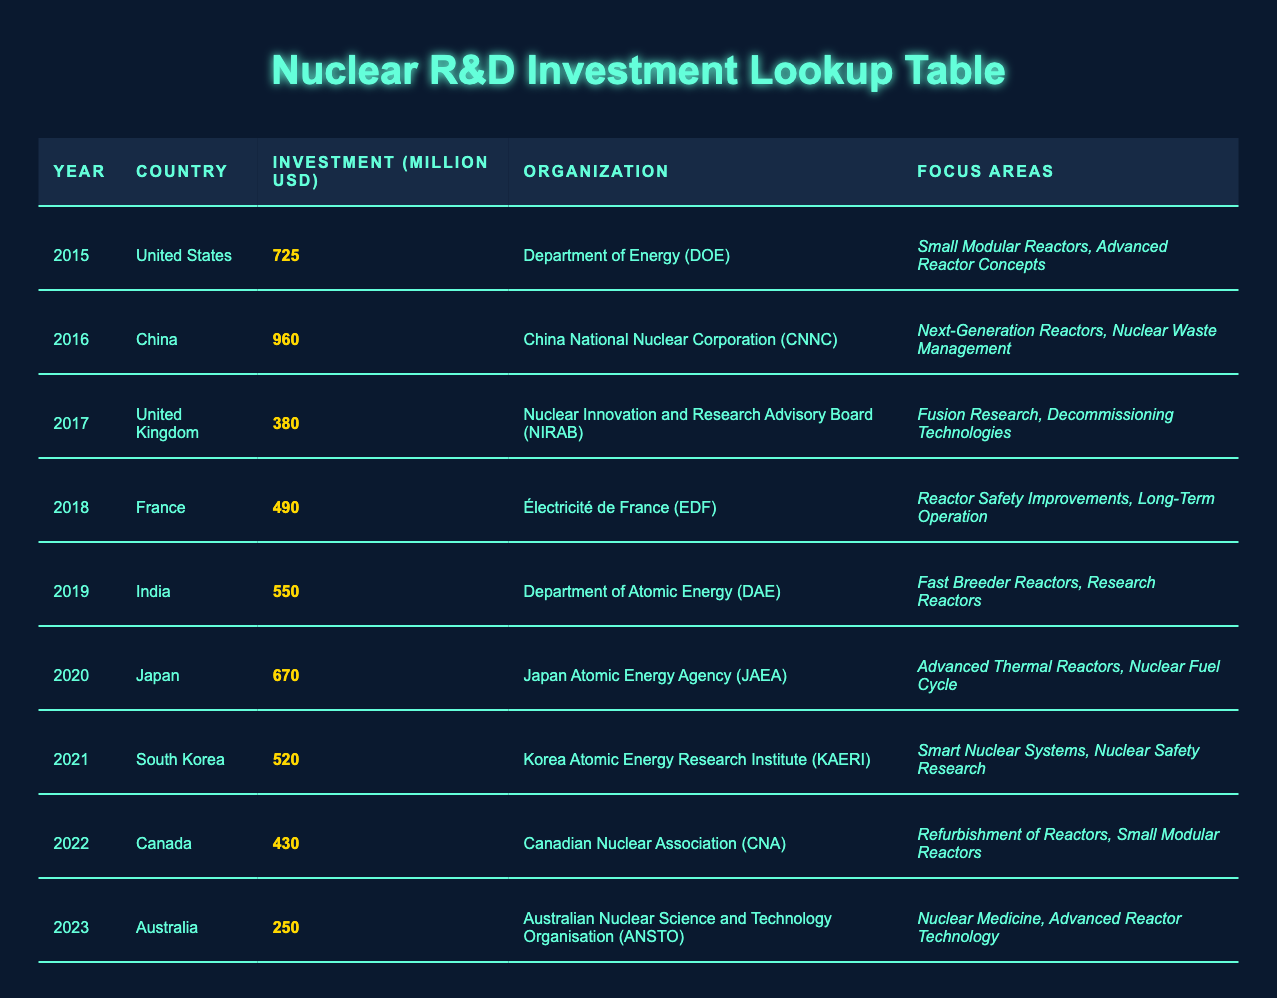What year had the highest investment in nuclear R&D? By reviewing the investment amounts listed for each year, we see that China in 2016 had an investment of 960 million USD, which is the highest amount compared to other years.
Answer: 2016 Which organization invested in nuclear R&D in Japan? The table specifies that the Japan Atomic Energy Agency (JAEA) was the organization responsible for nuclear R&D investment in Japan for the year 2020.
Answer: Japan Atomic Energy Agency (JAEA) How much did Canada invest in nuclear R&D in 2022? According to the table, Canada's investment in nuclear R&D in 2022 was 430 million USD, which is clearly stated in the respective row for that year.
Answer: 430 million USD What is the total investment in nuclear R&D from 2015 to 2020? To find the total investment from 2015 to 2020, we sum the investments for those years: 725 (2015) + 960 (2016) + 380 (2017) + 490 (2018) + 550 (2019) + 670 (2020) = 4075 million USD.
Answer: 4075 million USD Was any investment made in the field of Fusion Research? Yes, the table indicates that the United Kingdom, through the Nuclear Innovation and Research Advisory Board (NIRAB), invested in Fusion Research in 2017.
Answer: Yes Which country has the least investment in nuclear R&D, and what was the amount? By comparing all the investment amounts, we find that Australia had the lowest investment in 2023, with an amount of 250 million USD.
Answer: Australia, 250 million USD What was the average investment in nuclear R&D during the years listed in the table? Calculate the total investment from all the years (725 + 960 + 380 + 490 + 550 + 670 + 520 + 430 + 250) = 4575 million USD. There are 9 years, so the average is 4575 / 9 ≈ 508.33 million USD.
Answer: Approximately 508.33 million USD Did South Korea invest more than France in their respective years? South Korea invested 520 million USD in 2021, while France invested 490 million USD in 2018. Thus, South Korea's investment is greater than France's.
Answer: Yes What focus areas were targeted by the Department of Energy in the United States in 2015? The focus areas targeted by the Department of Energy (DOE) in the United States in 2015 were Small Modular Reactors and Advanced Reactor Concepts, as outlined in the table.
Answer: Small Modular Reactors, Advanced Reactor Concepts 